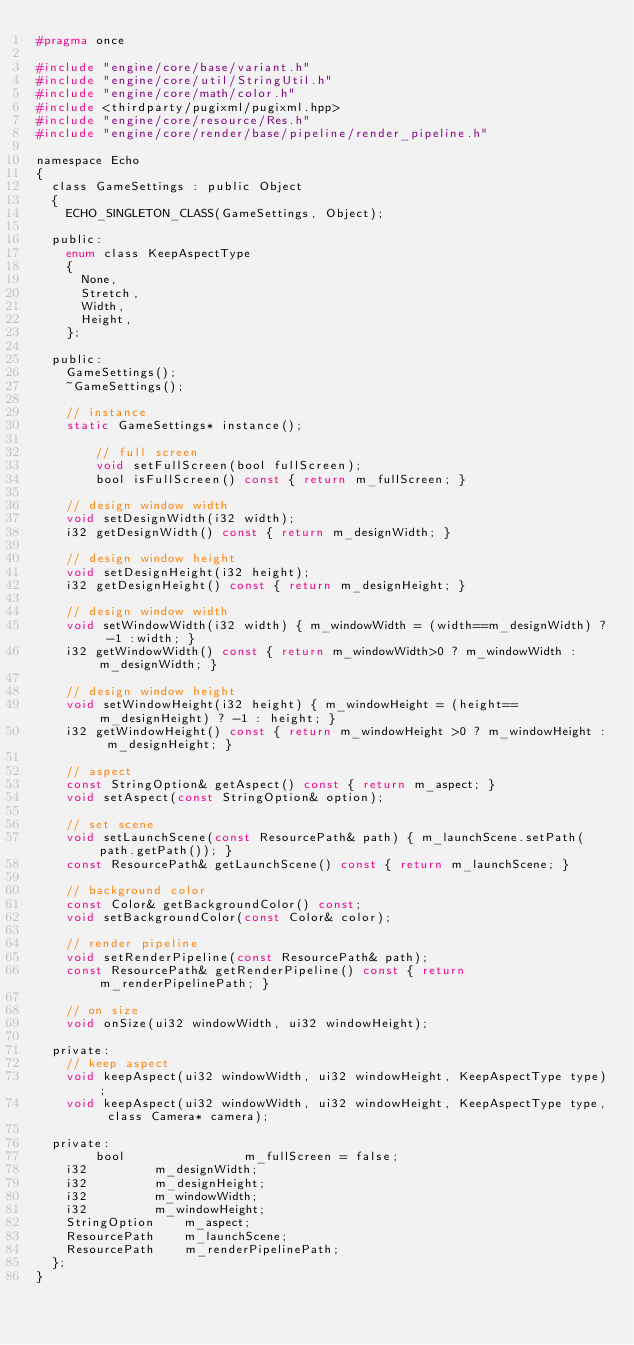Convert code to text. <code><loc_0><loc_0><loc_500><loc_500><_C_>#pragma once

#include "engine/core/base/variant.h"
#include "engine/core/util/StringUtil.h"
#include "engine/core/math/color.h"
#include <thirdparty/pugixml/pugixml.hpp>
#include "engine/core/resource/Res.h"
#include "engine/core/render/base/pipeline/render_pipeline.h"

namespace Echo
{
	class GameSettings : public Object
	{
		ECHO_SINGLETON_CLASS(GameSettings, Object);

	public:
		enum class KeepAspectType
		{
			None,
			Stretch,
			Width,
			Height,
		};

	public:
		GameSettings();
		~GameSettings();

		// instance
		static GameSettings* instance();
        
        // full screen
        void setFullScreen(bool fullScreen);
        bool isFullScreen() const { return m_fullScreen; }

		// design window width
		void setDesignWidth(i32 width);
		i32 getDesignWidth() const { return m_designWidth; }

		// design window height
		void setDesignHeight(i32 height);
		i32 getDesignHeight() const { return m_designHeight; }

		// design window width
		void setWindowWidth(i32 width) { m_windowWidth = (width==m_designWidth) ? -1 :width; }
		i32 getWindowWidth() const { return m_windowWidth>0 ? m_windowWidth : m_designWidth; }

		// design window height
		void setWindowHeight(i32 height) { m_windowHeight = (height==m_designHeight) ? -1 : height; }
		i32 getWindowHeight() const { return m_windowHeight >0 ? m_windowHeight : m_designHeight; }

		// aspect
		const StringOption& getAspect() const { return m_aspect; }
		void setAspect(const StringOption& option);

		// set scene
		void setLaunchScene(const ResourcePath& path) { m_launchScene.setPath(path.getPath()); }
		const ResourcePath& getLaunchScene() const { return m_launchScene; }

		// background color
		const Color& getBackgroundColor() const;
		void setBackgroundColor(const Color& color);

		// render pipeline
		void setRenderPipeline(const ResourcePath& path);
		const ResourcePath& getRenderPipeline() const { return m_renderPipelinePath; }

		// on size
		void onSize(ui32 windowWidth, ui32 windowHeight);

	private:
		// keep aspect
		void keepAspect(ui32 windowWidth, ui32 windowHeight, KeepAspectType type);
		void keepAspect(ui32 windowWidth, ui32 windowHeight, KeepAspectType type, class Camera* camera);

	private:
        bool                m_fullScreen = false;
		i32					m_designWidth;
		i32					m_designHeight;
		i32					m_windowWidth;
		i32					m_windowHeight;
		StringOption		m_aspect;
		ResourcePath		m_launchScene;
		ResourcePath		m_renderPipelinePath;
	};
}
</code> 